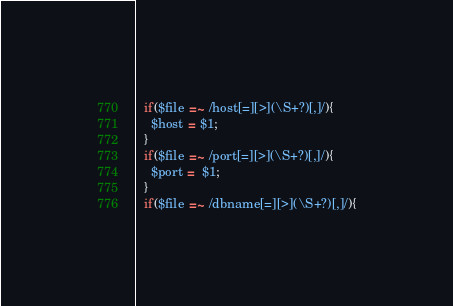Convert code to text. <code><loc_0><loc_0><loc_500><loc_500><_Perl_>  if($file =~ /host[=][>](\S+?)[,]/){
    $host = $1;
  }
  if($file =~ /port[=][>](\S+?)[,]/){
    $port =  $1;
  }
  if($file =~ /dbname[=][>](\S+?)[,]/){</code> 